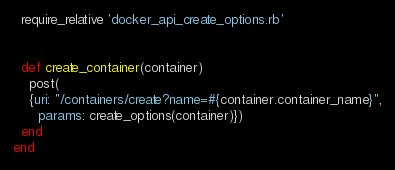<code> <loc_0><loc_0><loc_500><loc_500><_Ruby_>  require_relative 'docker_api_create_options.rb'


  def create_container(container)
    post(
    {uri: "/containers/create?name=#{container.container_name}",
      params: create_options(container)})
  end
end</code> 